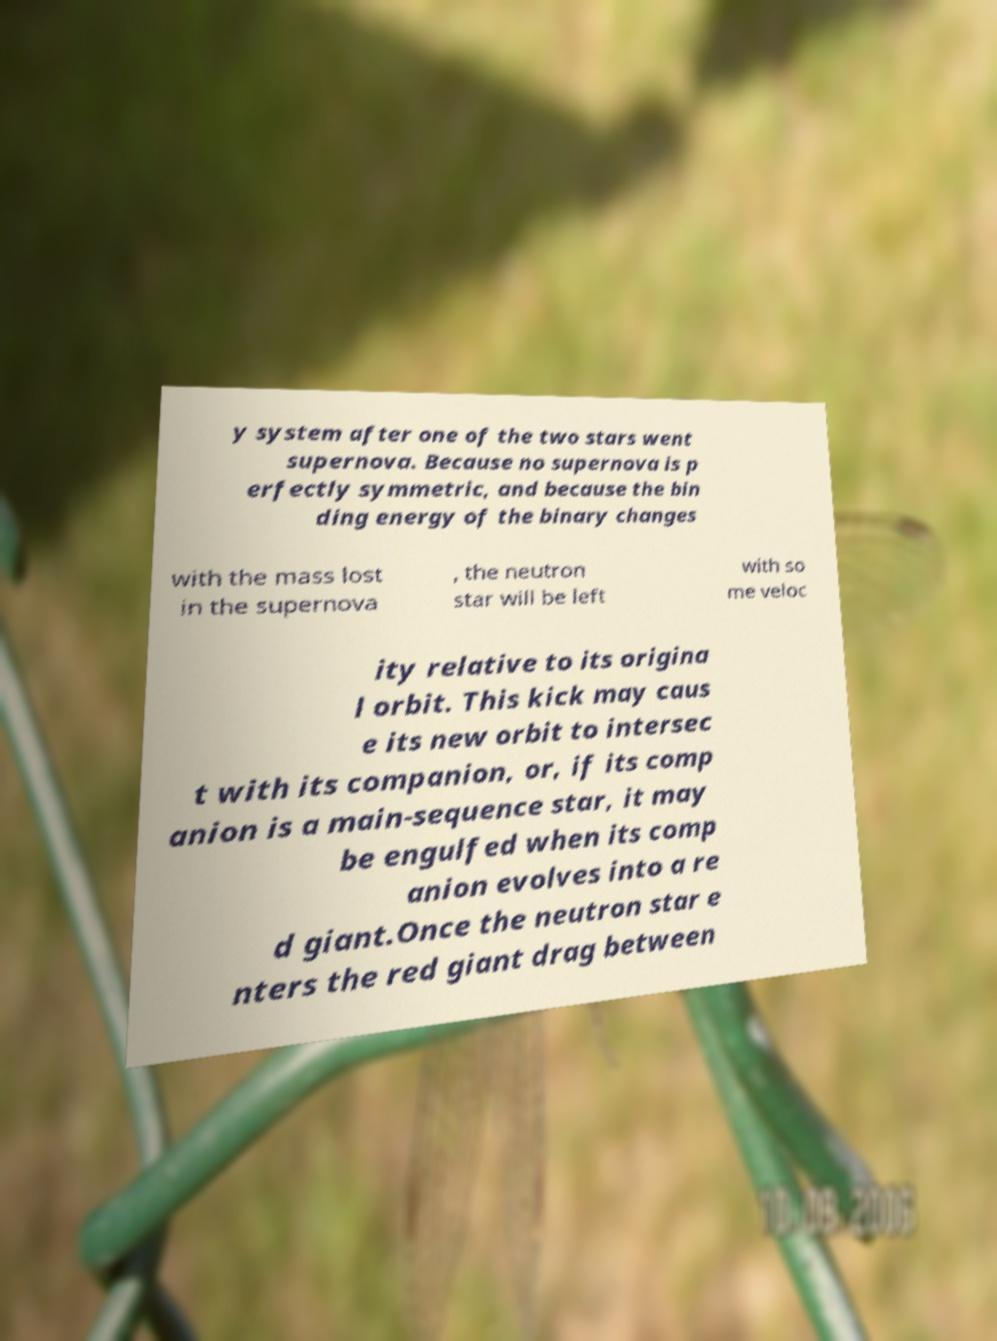What messages or text are displayed in this image? I need them in a readable, typed format. y system after one of the two stars went supernova. Because no supernova is p erfectly symmetric, and because the bin ding energy of the binary changes with the mass lost in the supernova , the neutron star will be left with so me veloc ity relative to its origina l orbit. This kick may caus e its new orbit to intersec t with its companion, or, if its comp anion is a main-sequence star, it may be engulfed when its comp anion evolves into a re d giant.Once the neutron star e nters the red giant drag between 